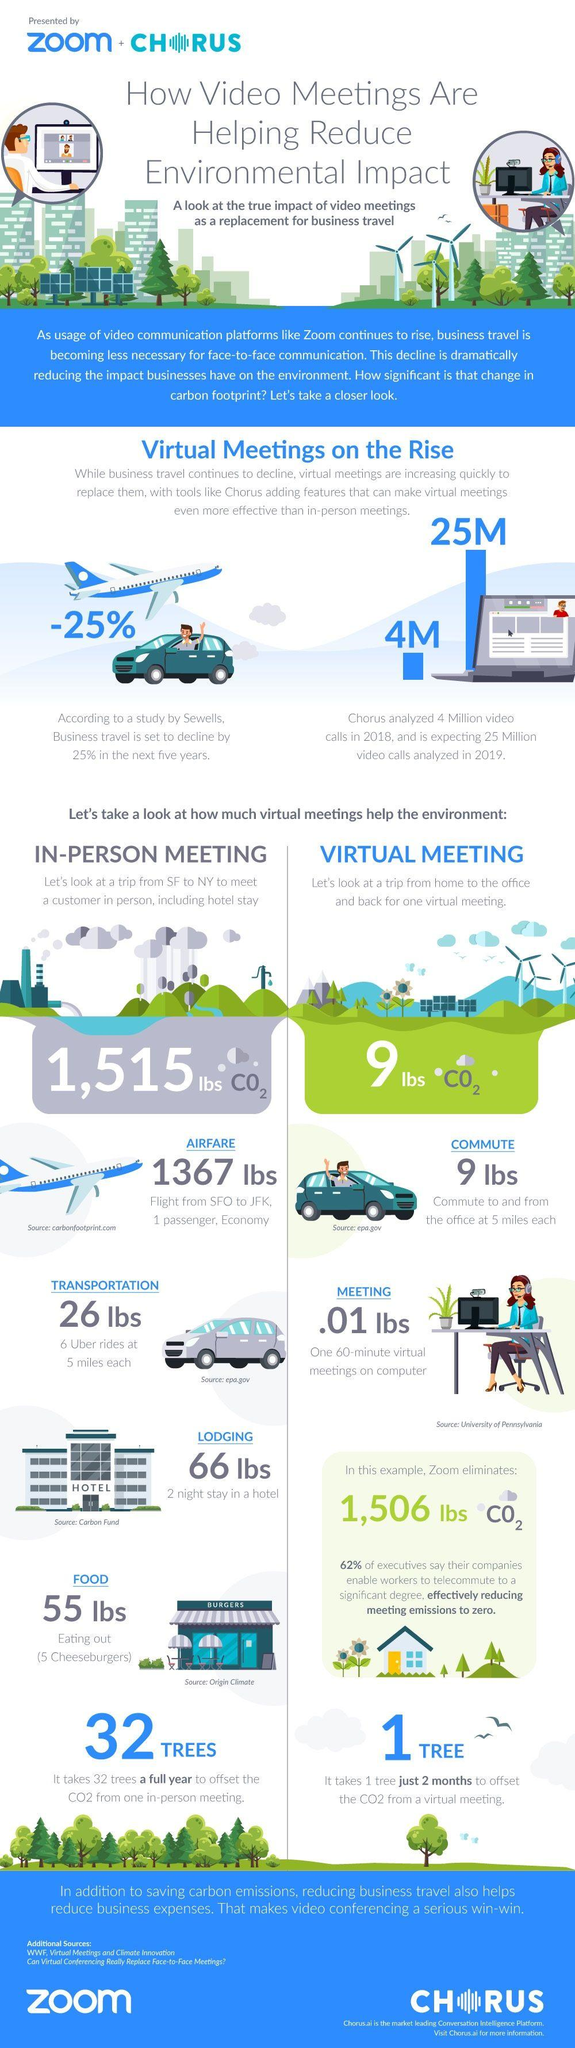Mention a couple of crucial points in this snapshot. There was a significant increase in the number of video calls from 2018 to 2019, with an increase of 21 million. 